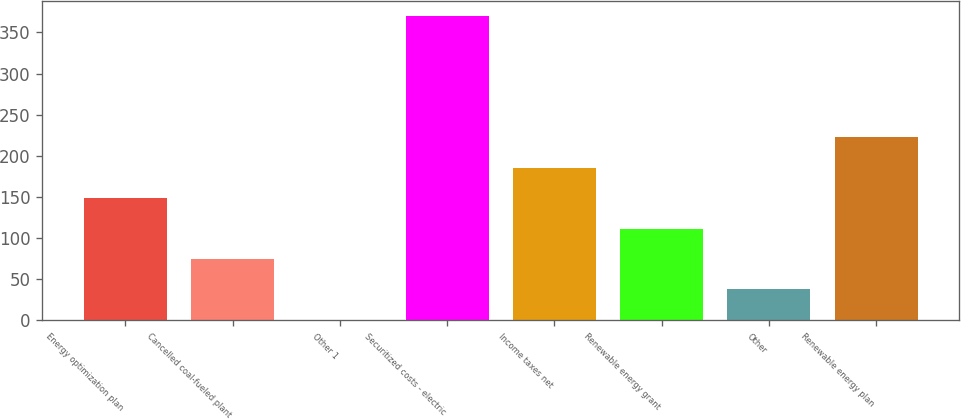<chart> <loc_0><loc_0><loc_500><loc_500><bar_chart><fcel>Energy optimization plan<fcel>Cancelled coal-fueled plant<fcel>Other 1<fcel>Securitized costs - electric<fcel>Income taxes net<fcel>Renewable energy grant<fcel>Other<fcel>Renewable energy plan<nl><fcel>148.6<fcel>74.8<fcel>1<fcel>370<fcel>185.5<fcel>111.7<fcel>37.9<fcel>222.4<nl></chart> 